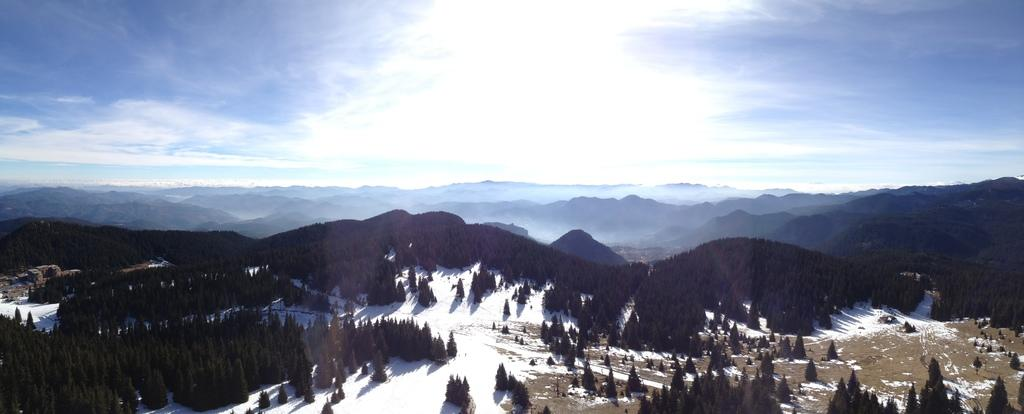What type of weather condition is depicted in the image? There is snow in the image, indicating a cold or wintery weather condition. What type of vegetation is present in the image? There are trees with green leaves in the image. What can be seen in the distance in the image? There are mountains visible in the background of the image. What is the color of the sky in the image? The sky is blue and white in color. What type of insurance policy does the chicken in the image have? There is no chicken present in the image, so it is not possible to determine what type of insurance policy it might have. 